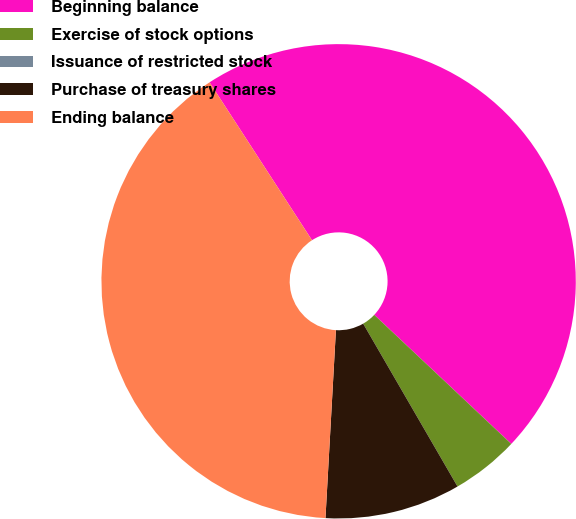<chart> <loc_0><loc_0><loc_500><loc_500><pie_chart><fcel>Beginning balance<fcel>Exercise of stock options<fcel>Issuance of restricted stock<fcel>Purchase of treasury shares<fcel>Ending balance<nl><fcel>46.18%<fcel>4.62%<fcel>0.0%<fcel>9.24%<fcel>39.96%<nl></chart> 